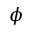Convert formula to latex. <formula><loc_0><loc_0><loc_500><loc_500>\phi</formula> 